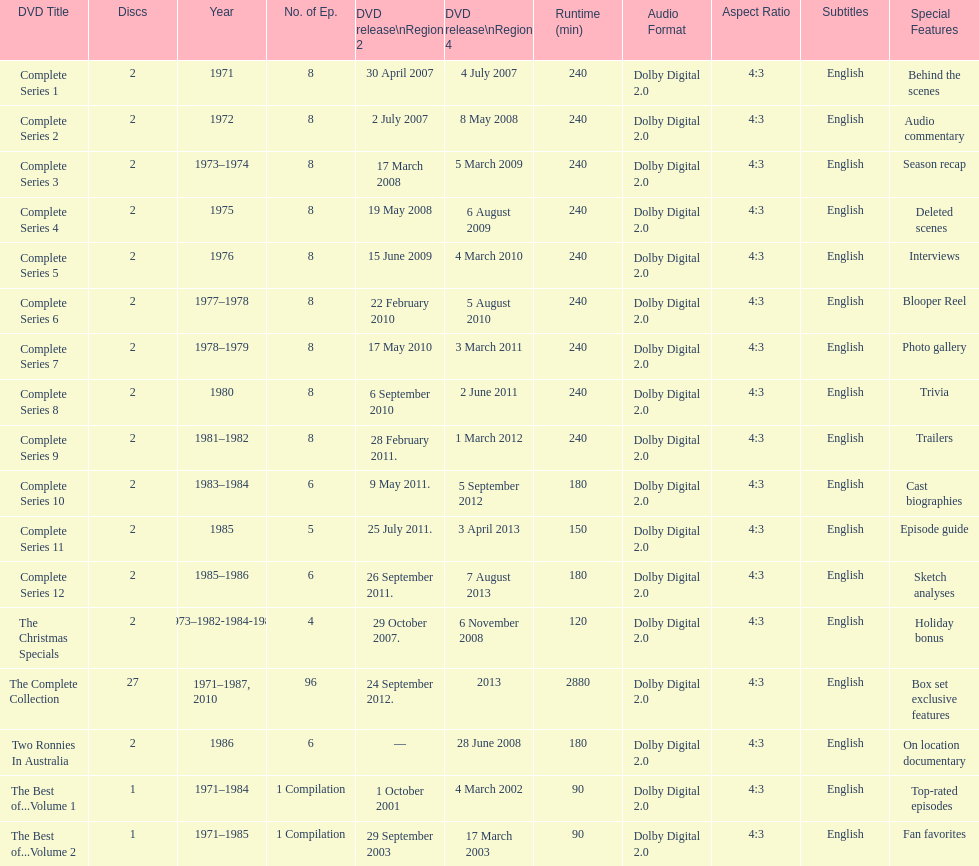Total number of episodes released in region 2 in 2007 20. 